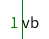Convert code to text. <code><loc_0><loc_0><loc_500><loc_500><_Python_>vb</code> 